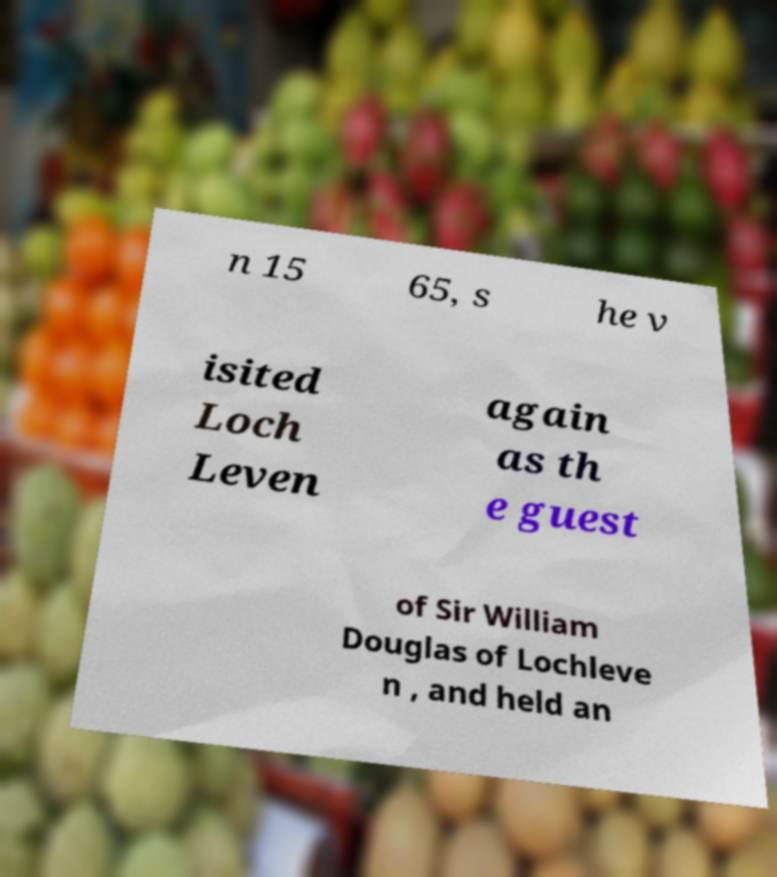Can you read and provide the text displayed in the image?This photo seems to have some interesting text. Can you extract and type it out for me? n 15 65, s he v isited Loch Leven again as th e guest of Sir William Douglas of Lochleve n , and held an 